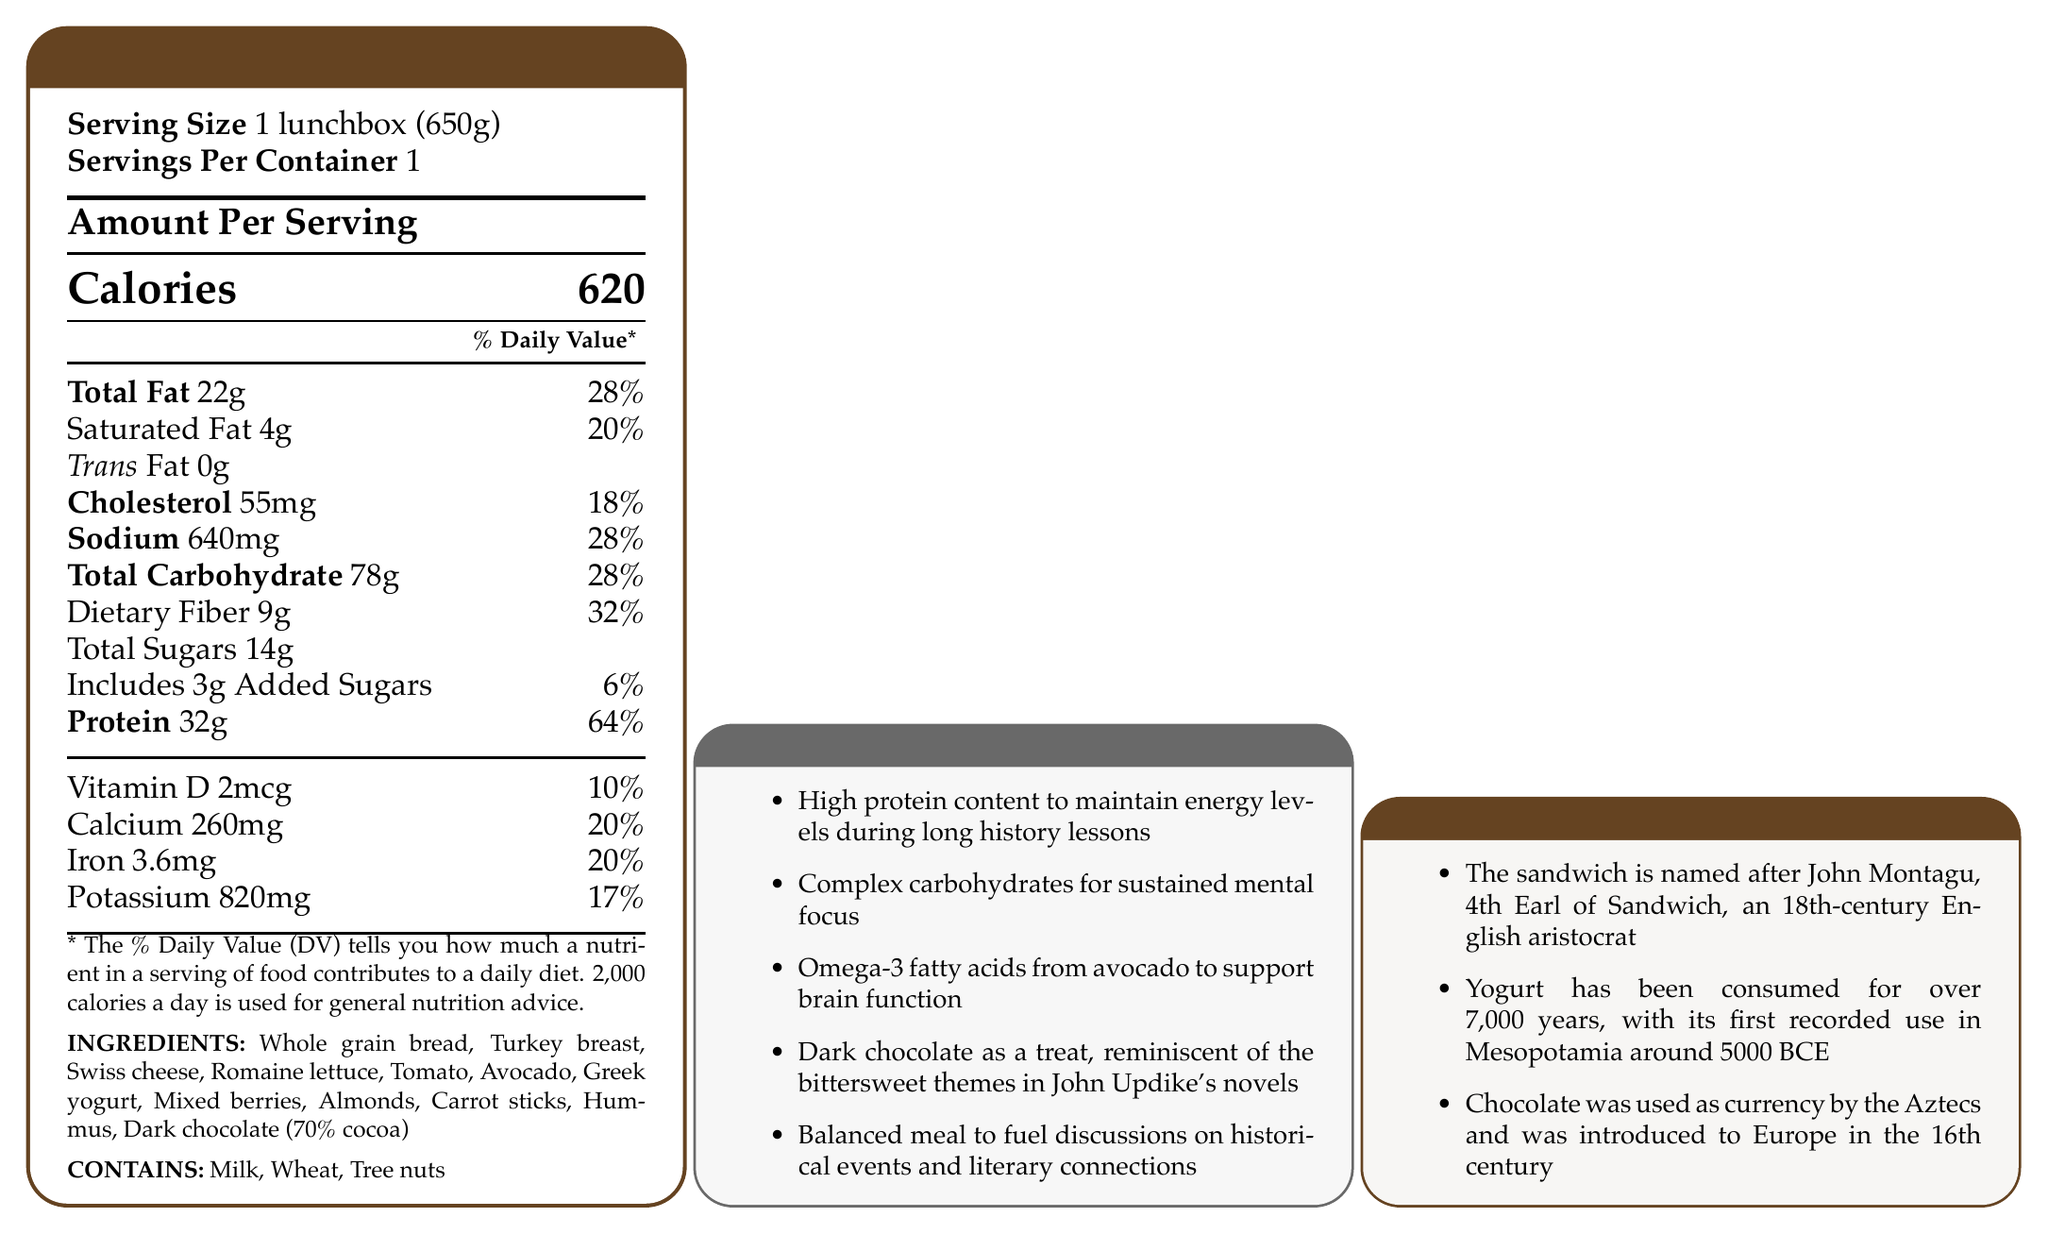What is the serving size mentioned in the document? The document states the serving size clearly under the "Serving Size" section.
Answer: 1 lunchbox (650g) What percentage of the daily value of protein does this meal provide? The document lists the protein content as 32g, providing 64% of the daily value.
Answer: 64% List two ingredients that are sources of omega-3 fatty acids. Avocado directly contains omega-3 fatty acids, and almonds have some omega-3 content as well.
Answer: Avocado, Almonds What is the total sodium content in the meal? The sodium content is listed as 640mg with 28% of the daily value.
Answer: 640mg Name an item included in the lunchbox designed as a treat. The teacher-specific notes mention dark chocolate as a treat.
Answer: Dark chocolate (70% cocoa) What percent of your daily value of calcium does this meal provide? Calcium content is listed as 260mg, which is 20% of the daily value.
Answer: 20% Which of the following is NOT an ingredient in the lunchbox? A. Whole grain bread B. Turkey breast C. Tuna D. Swiss cheese The list of ingredients includes whole grain bread, turkey breast, and Swiss cheese, but not tuna.
Answer: C. Tuna Which historical fact is mentioned about the sandwich? A. It was invented in France B. It is named after John Montagu C. It originated in the 20th century D. It was commonly eaten by Roman soldiers The historical food facts mention that the sandwich is named after John Montagu, 4th Earl of Sandwich.
Answer: B. It is named after John Montagu Does the lunchbox contain tree nuts? The allergens section clearly lists tree nuts as one of the allergens contained.
Answer: Yes Summarize the main components and purpose of the lunchbox as described in the document. The document outlines a balanced meal designed for sustained energy and mental focus, incorporating various nutrient-rich ingredients and a small treat, while also providing some historical context and thematic connections to literature.
Answer: The lunchbox contains a balanced variety of foods, including whole grain bread, turkey breast, Swiss cheese, romaine lettuce, tomato, avocado, Greek yogurt, mixed berries, almonds, carrot sticks, hummus, and dark chocolate. It aims to provide high protein, complex carbohydrates, and omega-3 fatty acids to support a history teacher’s energy levels and mental focus throughout a long day, while also providing a treat with dark chocolate, connecting to the bittersweet themes in John Updike's novels. What is the daily value percentage for added sugars in this meal? The document specifies that 3g of added sugars are included, which is 6% of the daily value.
Answer: 6% How many milligrams of iron does the meal contain? The meal contains 3.6mg of iron which is equivalent to 20% of the daily value.
Answer: 3.6mg Is the amount of saturated fat in the meal more than the amount of total fat? The saturated fat content is listed as 4g whereas the total fat content is 22g.
Answer: No What ancient civilization used chocolate as currency? The historical food facts mention that chocolate was used as currency by the Aztecs.
Answer: The Aztecs Can you determine the sodium content of the hummus specifically from the document? The document provides the total sodium content for the entire lunchbox but does not break it down by individual ingredients.
Answer: Cannot be determined 